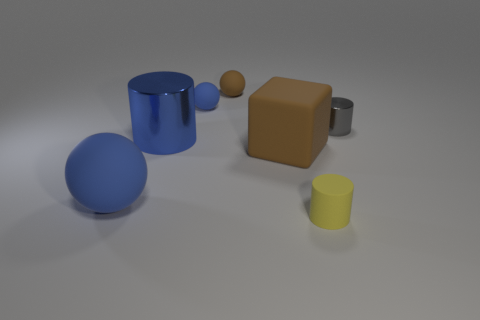Add 2 blue cylinders. How many objects exist? 9 Subtract all metal cylinders. How many cylinders are left? 1 Subtract all cylinders. How many objects are left? 4 Subtract all yellow cylinders. How many cylinders are left? 2 Subtract all cyan balls. How many blue cylinders are left? 1 Subtract all large matte things. Subtract all big matte objects. How many objects are left? 3 Add 4 large blue metallic objects. How many large blue metallic objects are left? 5 Add 3 tiny gray matte cylinders. How many tiny gray matte cylinders exist? 3 Subtract 1 blue cylinders. How many objects are left? 6 Subtract 1 cubes. How many cubes are left? 0 